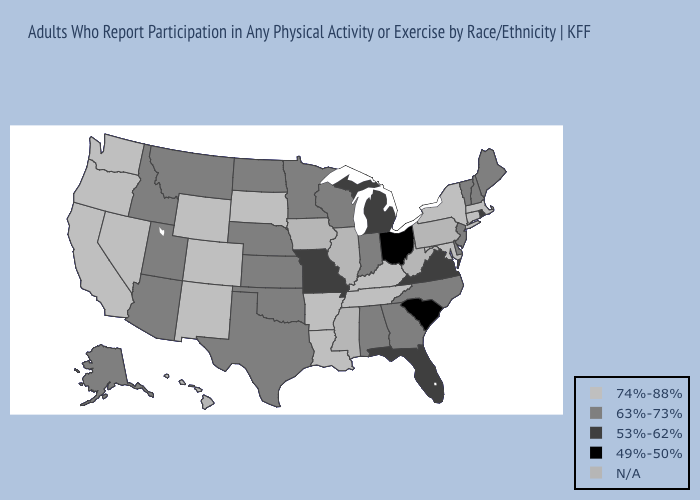What is the value of Alaska?
Write a very short answer. 63%-73%. What is the value of Massachusetts?
Be succinct. 74%-88%. Does Colorado have the lowest value in the USA?
Answer briefly. No. Does New Mexico have the lowest value in the West?
Short answer required. No. Does Ohio have the lowest value in the USA?
Keep it brief. Yes. Name the states that have a value in the range N/A?
Quick response, please. Hawaii, Illinois, Iowa, Mississippi, Pennsylvania, West Virginia. What is the value of Nevada?
Give a very brief answer. 74%-88%. Name the states that have a value in the range 74%-88%?
Concise answer only. Arkansas, California, Colorado, Connecticut, Kentucky, Louisiana, Maryland, Massachusetts, Nevada, New Mexico, New York, Oregon, South Dakota, Tennessee, Washington, Wyoming. What is the highest value in states that border New Jersey?
Be succinct. 74%-88%. Name the states that have a value in the range 49%-50%?
Write a very short answer. Ohio, South Carolina. Name the states that have a value in the range 49%-50%?
Keep it brief. Ohio, South Carolina. Among the states that border North Dakota , which have the highest value?
Short answer required. South Dakota. Which states have the lowest value in the South?
Be succinct. South Carolina. 